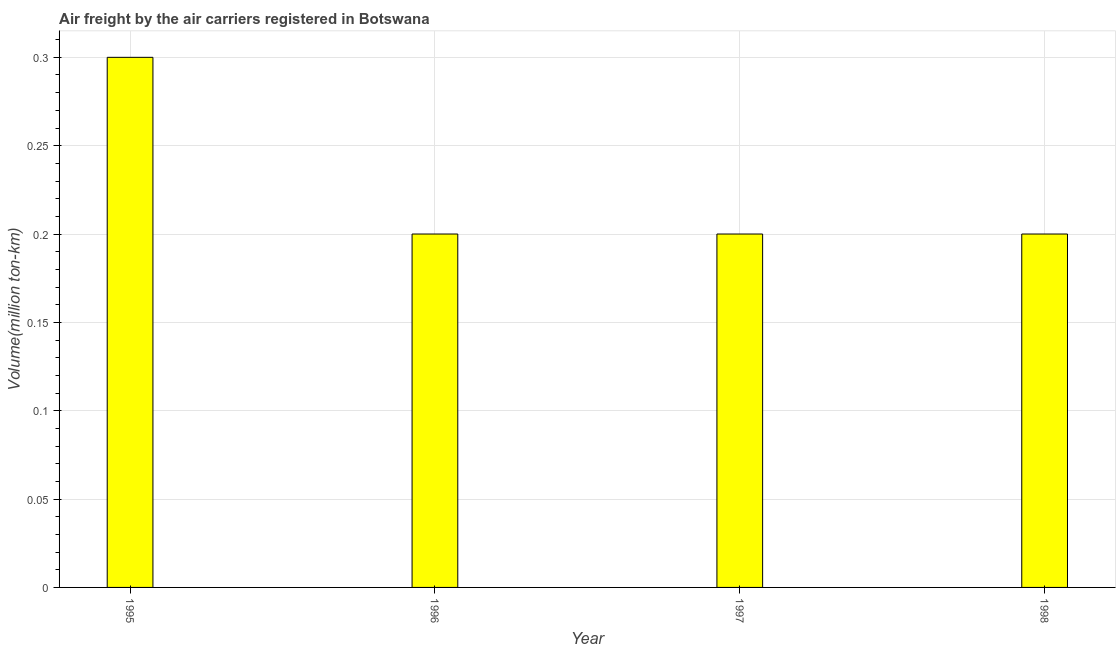Does the graph contain any zero values?
Your answer should be compact. No. What is the title of the graph?
Give a very brief answer. Air freight by the air carriers registered in Botswana. What is the label or title of the X-axis?
Your answer should be very brief. Year. What is the label or title of the Y-axis?
Offer a very short reply. Volume(million ton-km). What is the air freight in 1996?
Provide a short and direct response. 0.2. Across all years, what is the maximum air freight?
Your response must be concise. 0.3. Across all years, what is the minimum air freight?
Offer a very short reply. 0.2. In which year was the air freight maximum?
Keep it short and to the point. 1995. In which year was the air freight minimum?
Your answer should be very brief. 1996. What is the sum of the air freight?
Offer a terse response. 0.9. What is the average air freight per year?
Provide a succinct answer. 0.23. What is the median air freight?
Your answer should be very brief. 0.2. What is the ratio of the air freight in 1995 to that in 1996?
Your answer should be compact. 1.5. Is the difference between the air freight in 1997 and 1998 greater than the difference between any two years?
Ensure brevity in your answer.  No. What is the difference between the highest and the second highest air freight?
Ensure brevity in your answer.  0.1. Is the sum of the air freight in 1995 and 1998 greater than the maximum air freight across all years?
Ensure brevity in your answer.  Yes. In how many years, is the air freight greater than the average air freight taken over all years?
Ensure brevity in your answer.  1. What is the difference between two consecutive major ticks on the Y-axis?
Your response must be concise. 0.05. Are the values on the major ticks of Y-axis written in scientific E-notation?
Provide a succinct answer. No. What is the Volume(million ton-km) of 1995?
Your answer should be very brief. 0.3. What is the Volume(million ton-km) of 1996?
Offer a terse response. 0.2. What is the Volume(million ton-km) in 1997?
Offer a terse response. 0.2. What is the Volume(million ton-km) of 1998?
Make the answer very short. 0.2. What is the difference between the Volume(million ton-km) in 1995 and 1996?
Provide a short and direct response. 0.1. What is the difference between the Volume(million ton-km) in 1995 and 1997?
Provide a succinct answer. 0.1. What is the difference between the Volume(million ton-km) in 1995 and 1998?
Your answer should be very brief. 0.1. What is the difference between the Volume(million ton-km) in 1997 and 1998?
Keep it short and to the point. 0. What is the ratio of the Volume(million ton-km) in 1995 to that in 1996?
Keep it short and to the point. 1.5. What is the ratio of the Volume(million ton-km) in 1995 to that in 1997?
Make the answer very short. 1.5. What is the ratio of the Volume(million ton-km) in 1996 to that in 1997?
Give a very brief answer. 1. What is the ratio of the Volume(million ton-km) in 1996 to that in 1998?
Make the answer very short. 1. What is the ratio of the Volume(million ton-km) in 1997 to that in 1998?
Provide a short and direct response. 1. 